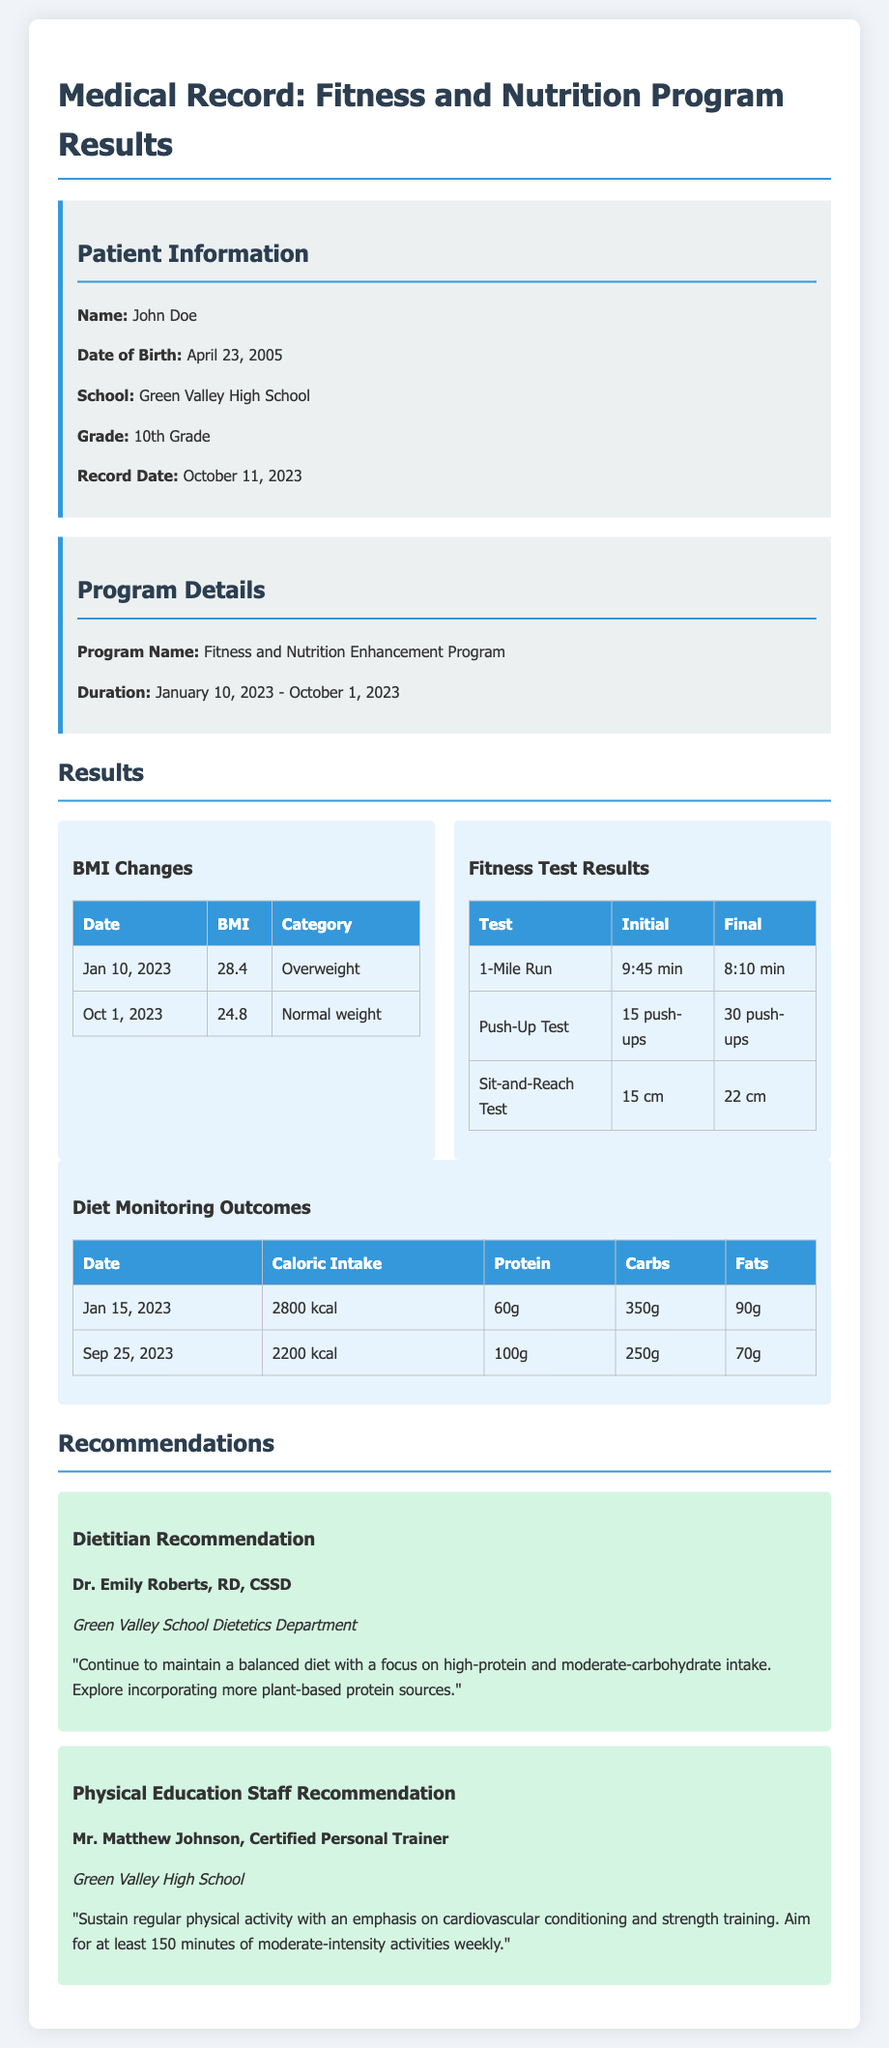What is the patient's name? The patient's name is listed at the beginning of the document under Patient Information.
Answer: John Doe What was the initial BMI on January 10, 2023? The initial BMI is specified in the BMI Changes section of the document.
Answer: 28.4 What recommendation did Dr. Emily Roberts make? This recommendation is found under the Dietitian Recommendation section, providing guidance on dietary habits.
Answer: "Continue to maintain a balanced diet with a focus on high-protein and moderate-carbohydrate intake." How many push-ups could the patient perform initially? The initial number of push-ups is shown in the Fitness Test Results section.
Answer: 15 push-ups What is the patient's final weight category? The final weight category is determined by the BMI listed on October 1, 2023.
Answer: Normal weight What is the total caloric intake on September 25, 2023? This information is provided in the Diet Monitoring Outcomes table for that date.
Answer: 2200 kcal What improvement was observed in the Sit-and-Reach test? This is calculated by comparing the initial and final results listed in the Fitness Test Results section.
Answer: 7 cm How long did the program last? The program duration is provided in the Program Details section of the document.
Answer: January 10, 2023 - October 1, 2023 